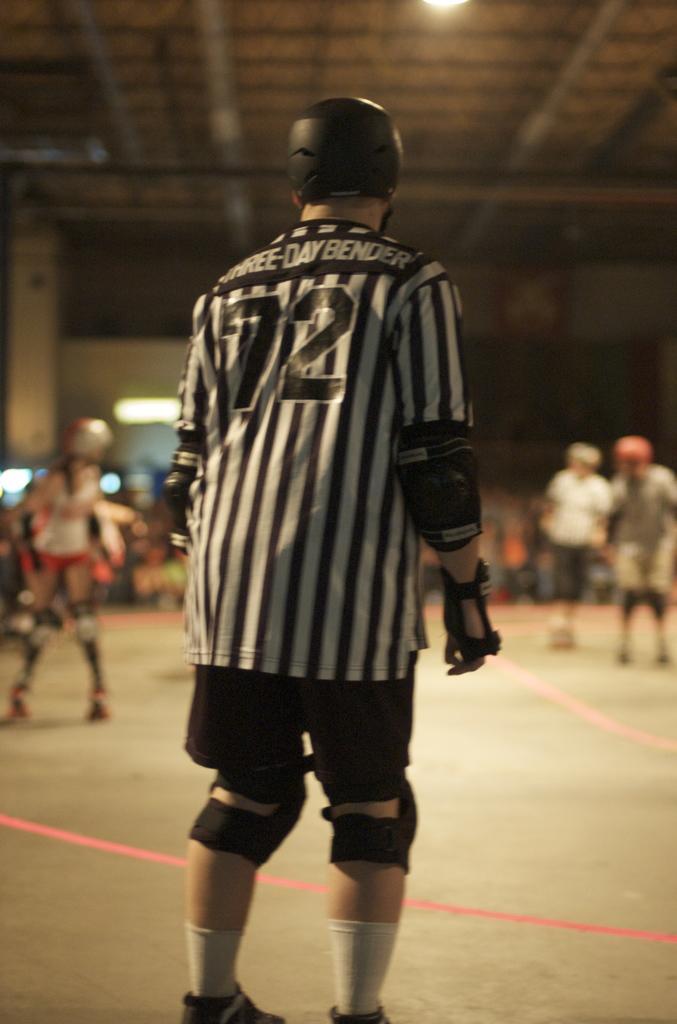Could you give a brief overview of what you see in this image? In the foreground I can see a person standing on the floor. The person is wearing a black color T-shirt and a short. I can see a helmet on the head and safety leg pads on the knees. I can see a woman on the left side and two persons on the right side. There is a lamp at the top of the picture. 